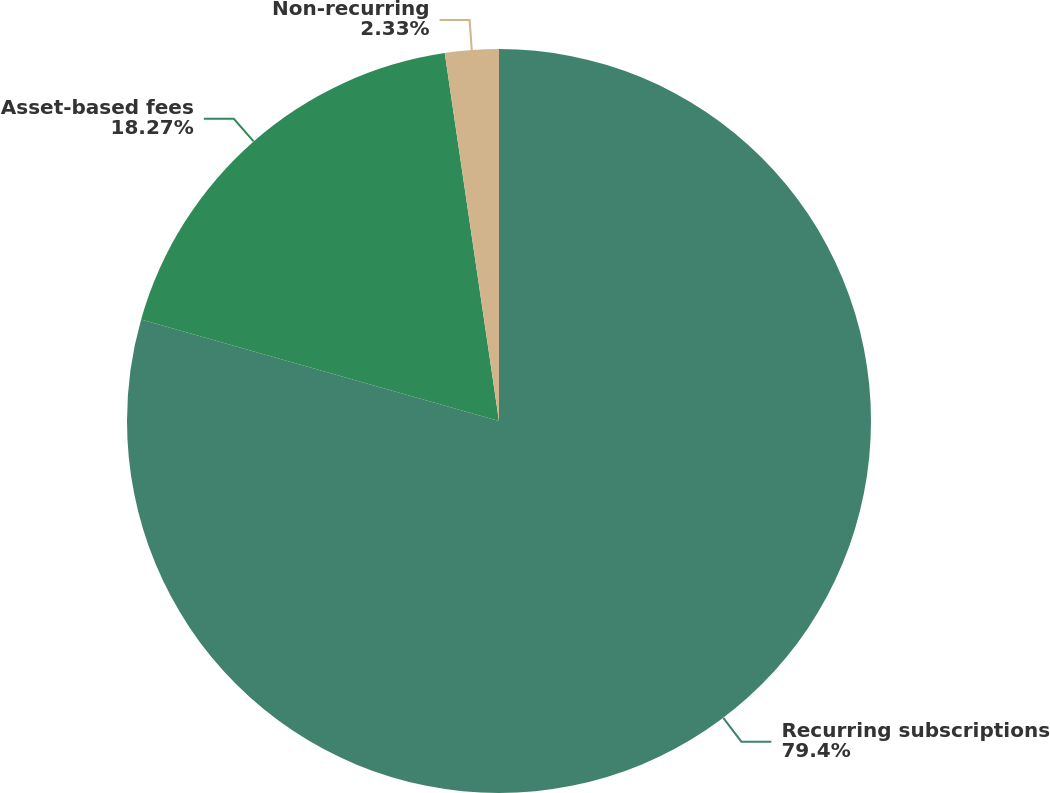Convert chart. <chart><loc_0><loc_0><loc_500><loc_500><pie_chart><fcel>Recurring subscriptions<fcel>Asset-based fees<fcel>Non-recurring<nl><fcel>79.4%<fcel>18.27%<fcel>2.33%<nl></chart> 